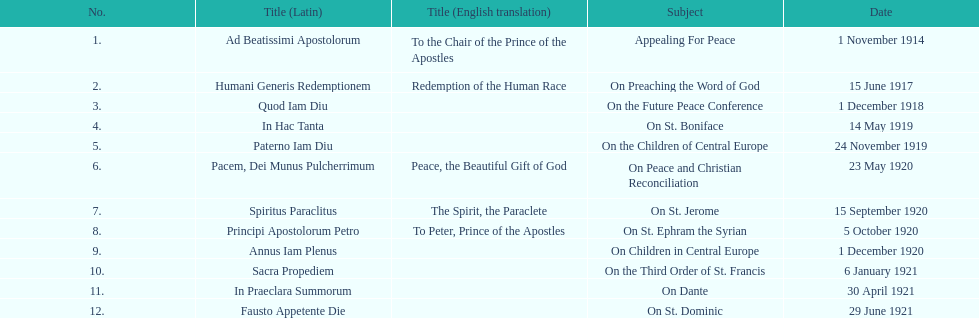How many titles are listed in the table? 12. 